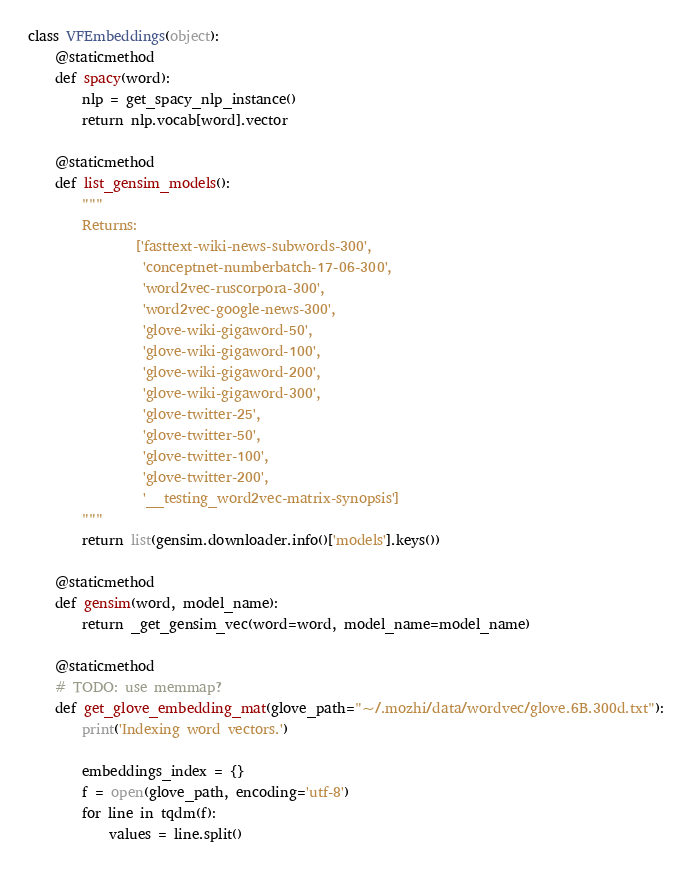<code> <loc_0><loc_0><loc_500><loc_500><_Python_>

class VFEmbeddings(object):
    @staticmethod
    def spacy(word):
        nlp = get_spacy_nlp_instance()
        return nlp.vocab[word].vector

    @staticmethod
    def list_gensim_models():
        """
        Returns:
                ['fasttext-wiki-news-subwords-300',
                 'conceptnet-numberbatch-17-06-300',
                 'word2vec-ruscorpora-300',
                 'word2vec-google-news-300',
                 'glove-wiki-gigaword-50',
                 'glove-wiki-gigaword-100',
                 'glove-wiki-gigaword-200',
                 'glove-wiki-gigaword-300',
                 'glove-twitter-25',
                 'glove-twitter-50',
                 'glove-twitter-100',
                 'glove-twitter-200',
                 '__testing_word2vec-matrix-synopsis']
        """
        return list(gensim.downloader.info()['models'].keys())

    @staticmethod
    def gensim(word, model_name):
        return _get_gensim_vec(word=word, model_name=model_name)

    @staticmethod
    # TODO: use memmap?
    def get_glove_embedding_mat(glove_path="~/.mozhi/data/wordvec/glove.6B.300d.txt"):
        print('Indexing word vectors.')

        embeddings_index = {}
        f = open(glove_path, encoding='utf-8')
        for line in tqdm(f):
            values = line.split()</code> 